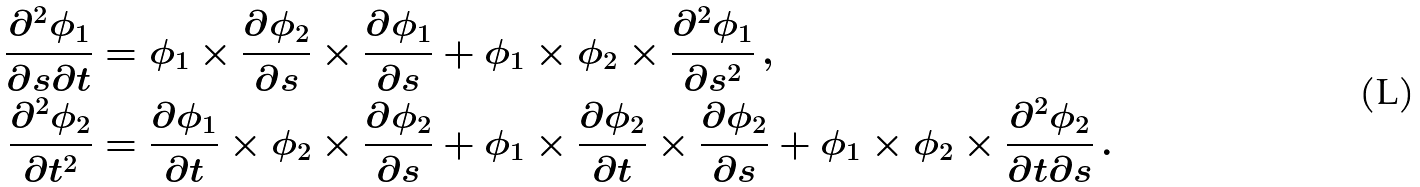Convert formula to latex. <formula><loc_0><loc_0><loc_500><loc_500>\frac { \partial ^ { 2 } \phi _ { 1 } } { \partial s \partial t } & = \phi _ { 1 } \times \frac { \partial \phi _ { 2 } } { \partial s } \times \frac { \partial \phi _ { 1 } } { \partial s } + \phi _ { 1 } \times \phi _ { 2 } \times \frac { \partial ^ { 2 } \phi _ { 1 } } { \partial s ^ { 2 } } \, , \\ \frac { \partial ^ { 2 } \phi _ { 2 } } { \partial t ^ { 2 } } & = \frac { \partial \phi _ { 1 } } { \partial t } \times \phi _ { 2 } \times \frac { \partial \phi _ { 2 } } { \partial s } + \phi _ { 1 } \times \frac { \partial \phi _ { 2 } } { \partial t } \times \frac { \partial \phi _ { 2 } } { \partial s } + \phi _ { 1 } \times \phi _ { 2 } \times \frac { \partial ^ { 2 } \phi _ { 2 } } { \partial t \partial s } \, .</formula> 